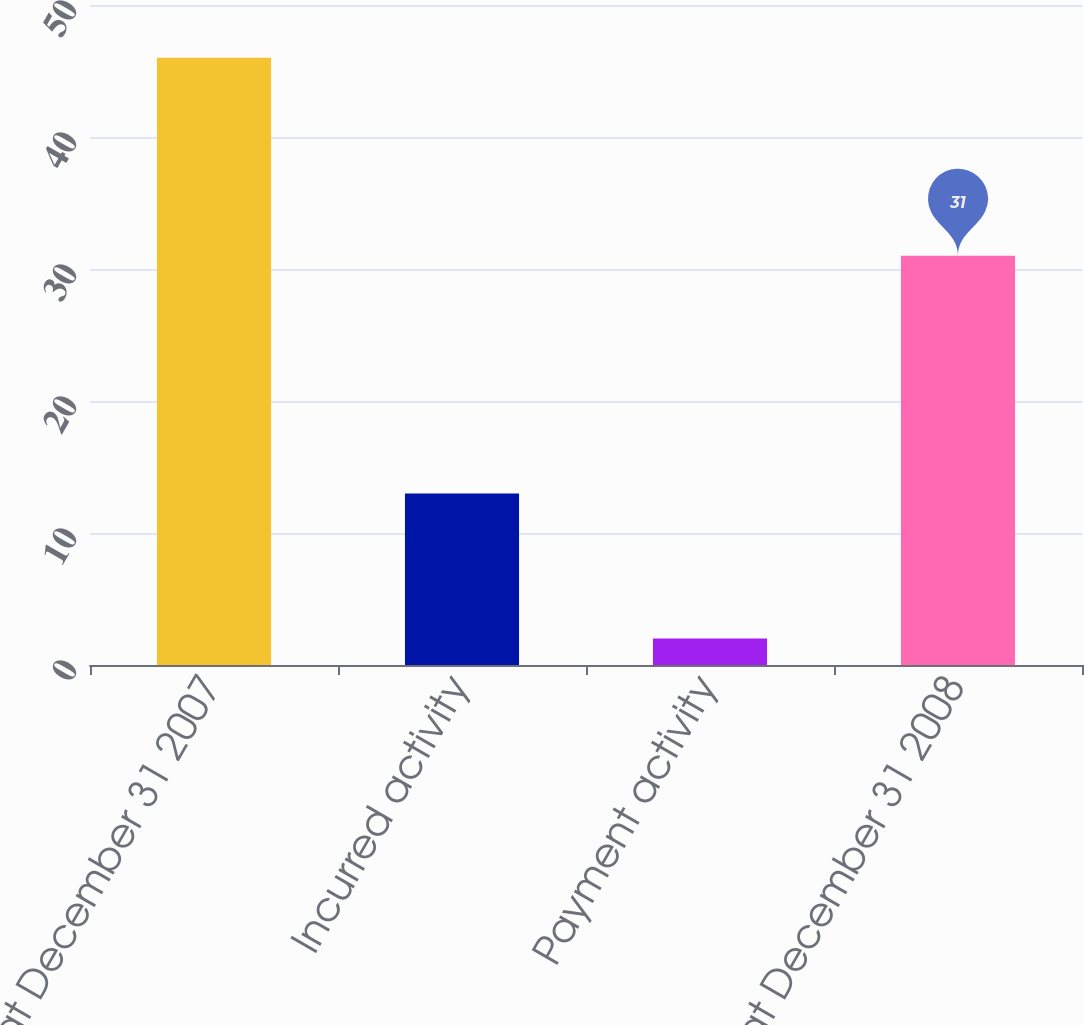Convert chart to OTSL. <chart><loc_0><loc_0><loc_500><loc_500><bar_chart><fcel>Balance at December 31 2007<fcel>Incurred activity<fcel>Payment activity<fcel>Balance at December 31 2008<nl><fcel>46<fcel>13<fcel>2<fcel>31<nl></chart> 